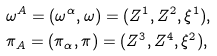Convert formula to latex. <formula><loc_0><loc_0><loc_500><loc_500>& \omega ^ { A } = ( \omega ^ { \alpha } , \omega ) = ( Z ^ { 1 } , Z ^ { 2 } , \xi ^ { 1 } ) , \\ & \pi _ { A } = ( \pi _ { \alpha } , \pi ) = ( Z ^ { 3 } , Z ^ { 4 } , \xi ^ { 2 } ) ,</formula> 